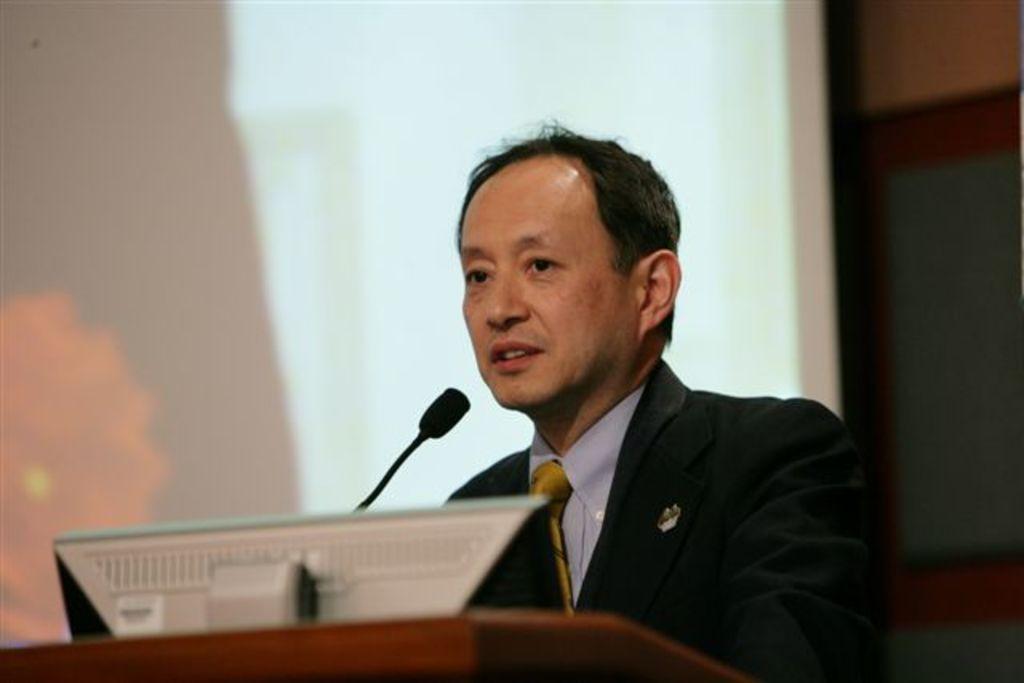How would you summarize this image in a sentence or two? In this image there is a person wearing a blazer and a tie. Before him there is a podium having a screen and a mike. Behind him there is a screen. Background there is a wall. 